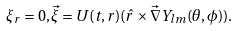Convert formula to latex. <formula><loc_0><loc_0><loc_500><loc_500>\xi _ { r } = 0 , \vec { \xi } = U ( t , r ) ( \hat { r } \times \vec { \nabla } Y _ { l m } ( \theta , \phi ) ) .</formula> 